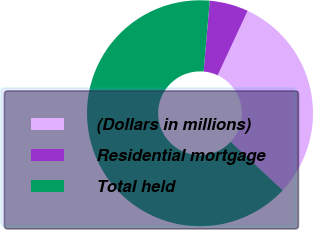<chart> <loc_0><loc_0><loc_500><loc_500><pie_chart><fcel>(Dollars in millions)<fcel>Residential mortgage<fcel>Total held<nl><fcel>30.01%<fcel>5.56%<fcel>64.43%<nl></chart> 